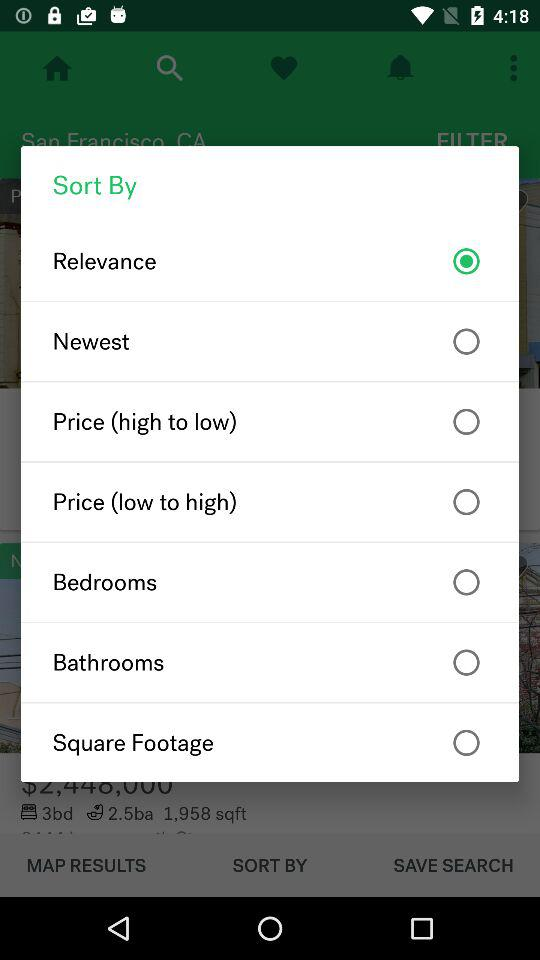Is "Newest" selected or not? "Newest" is not selected. 